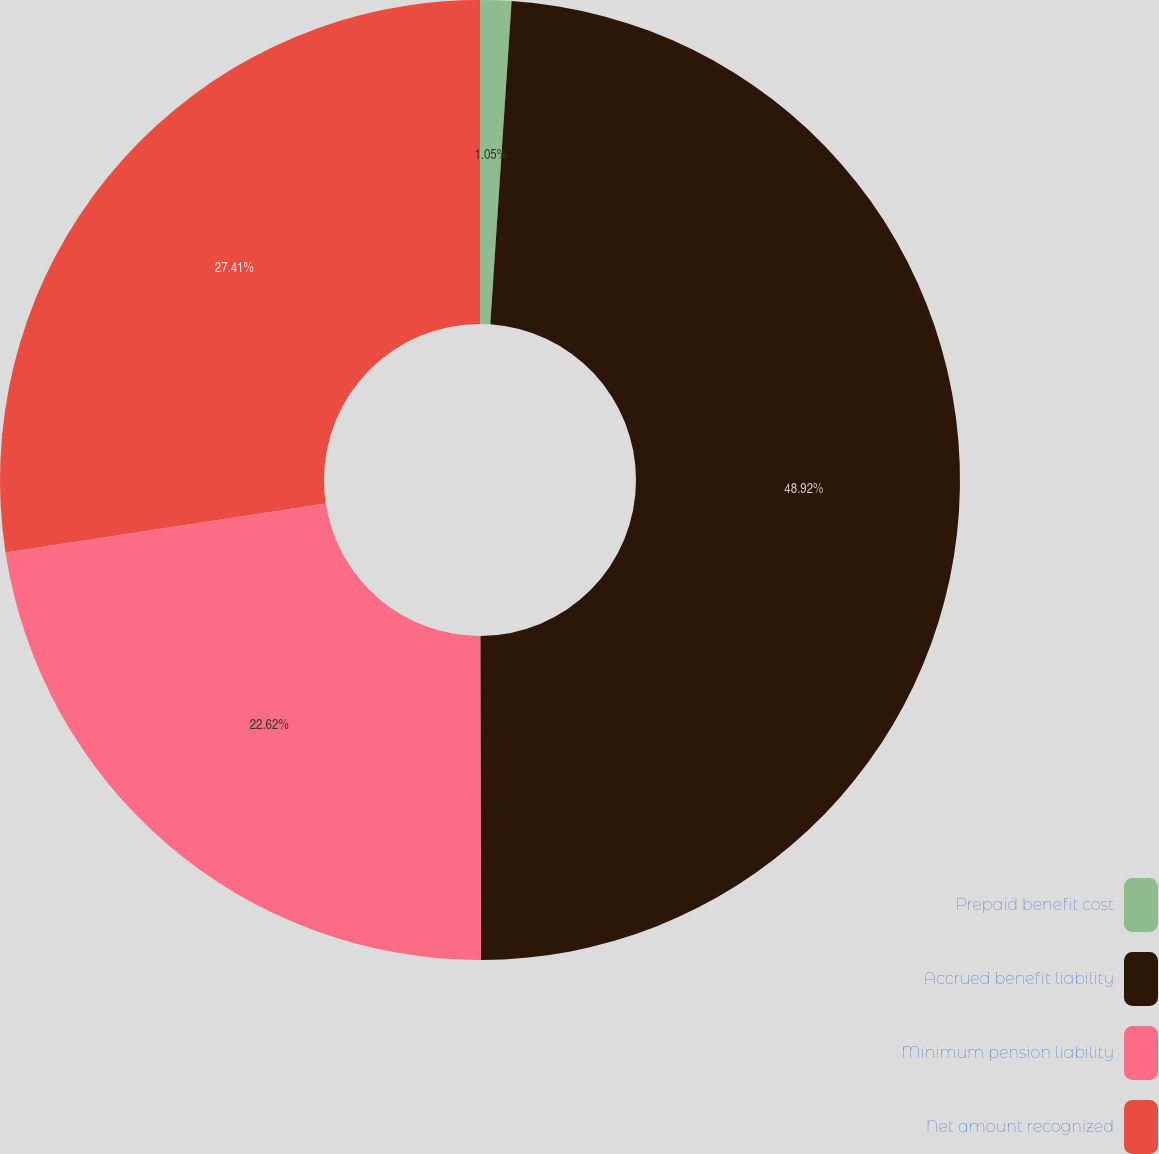Convert chart. <chart><loc_0><loc_0><loc_500><loc_500><pie_chart><fcel>Prepaid benefit cost<fcel>Accrued benefit liability<fcel>Minimum pension liability<fcel>Net amount recognized<nl><fcel>1.05%<fcel>48.92%<fcel>22.62%<fcel>27.41%<nl></chart> 